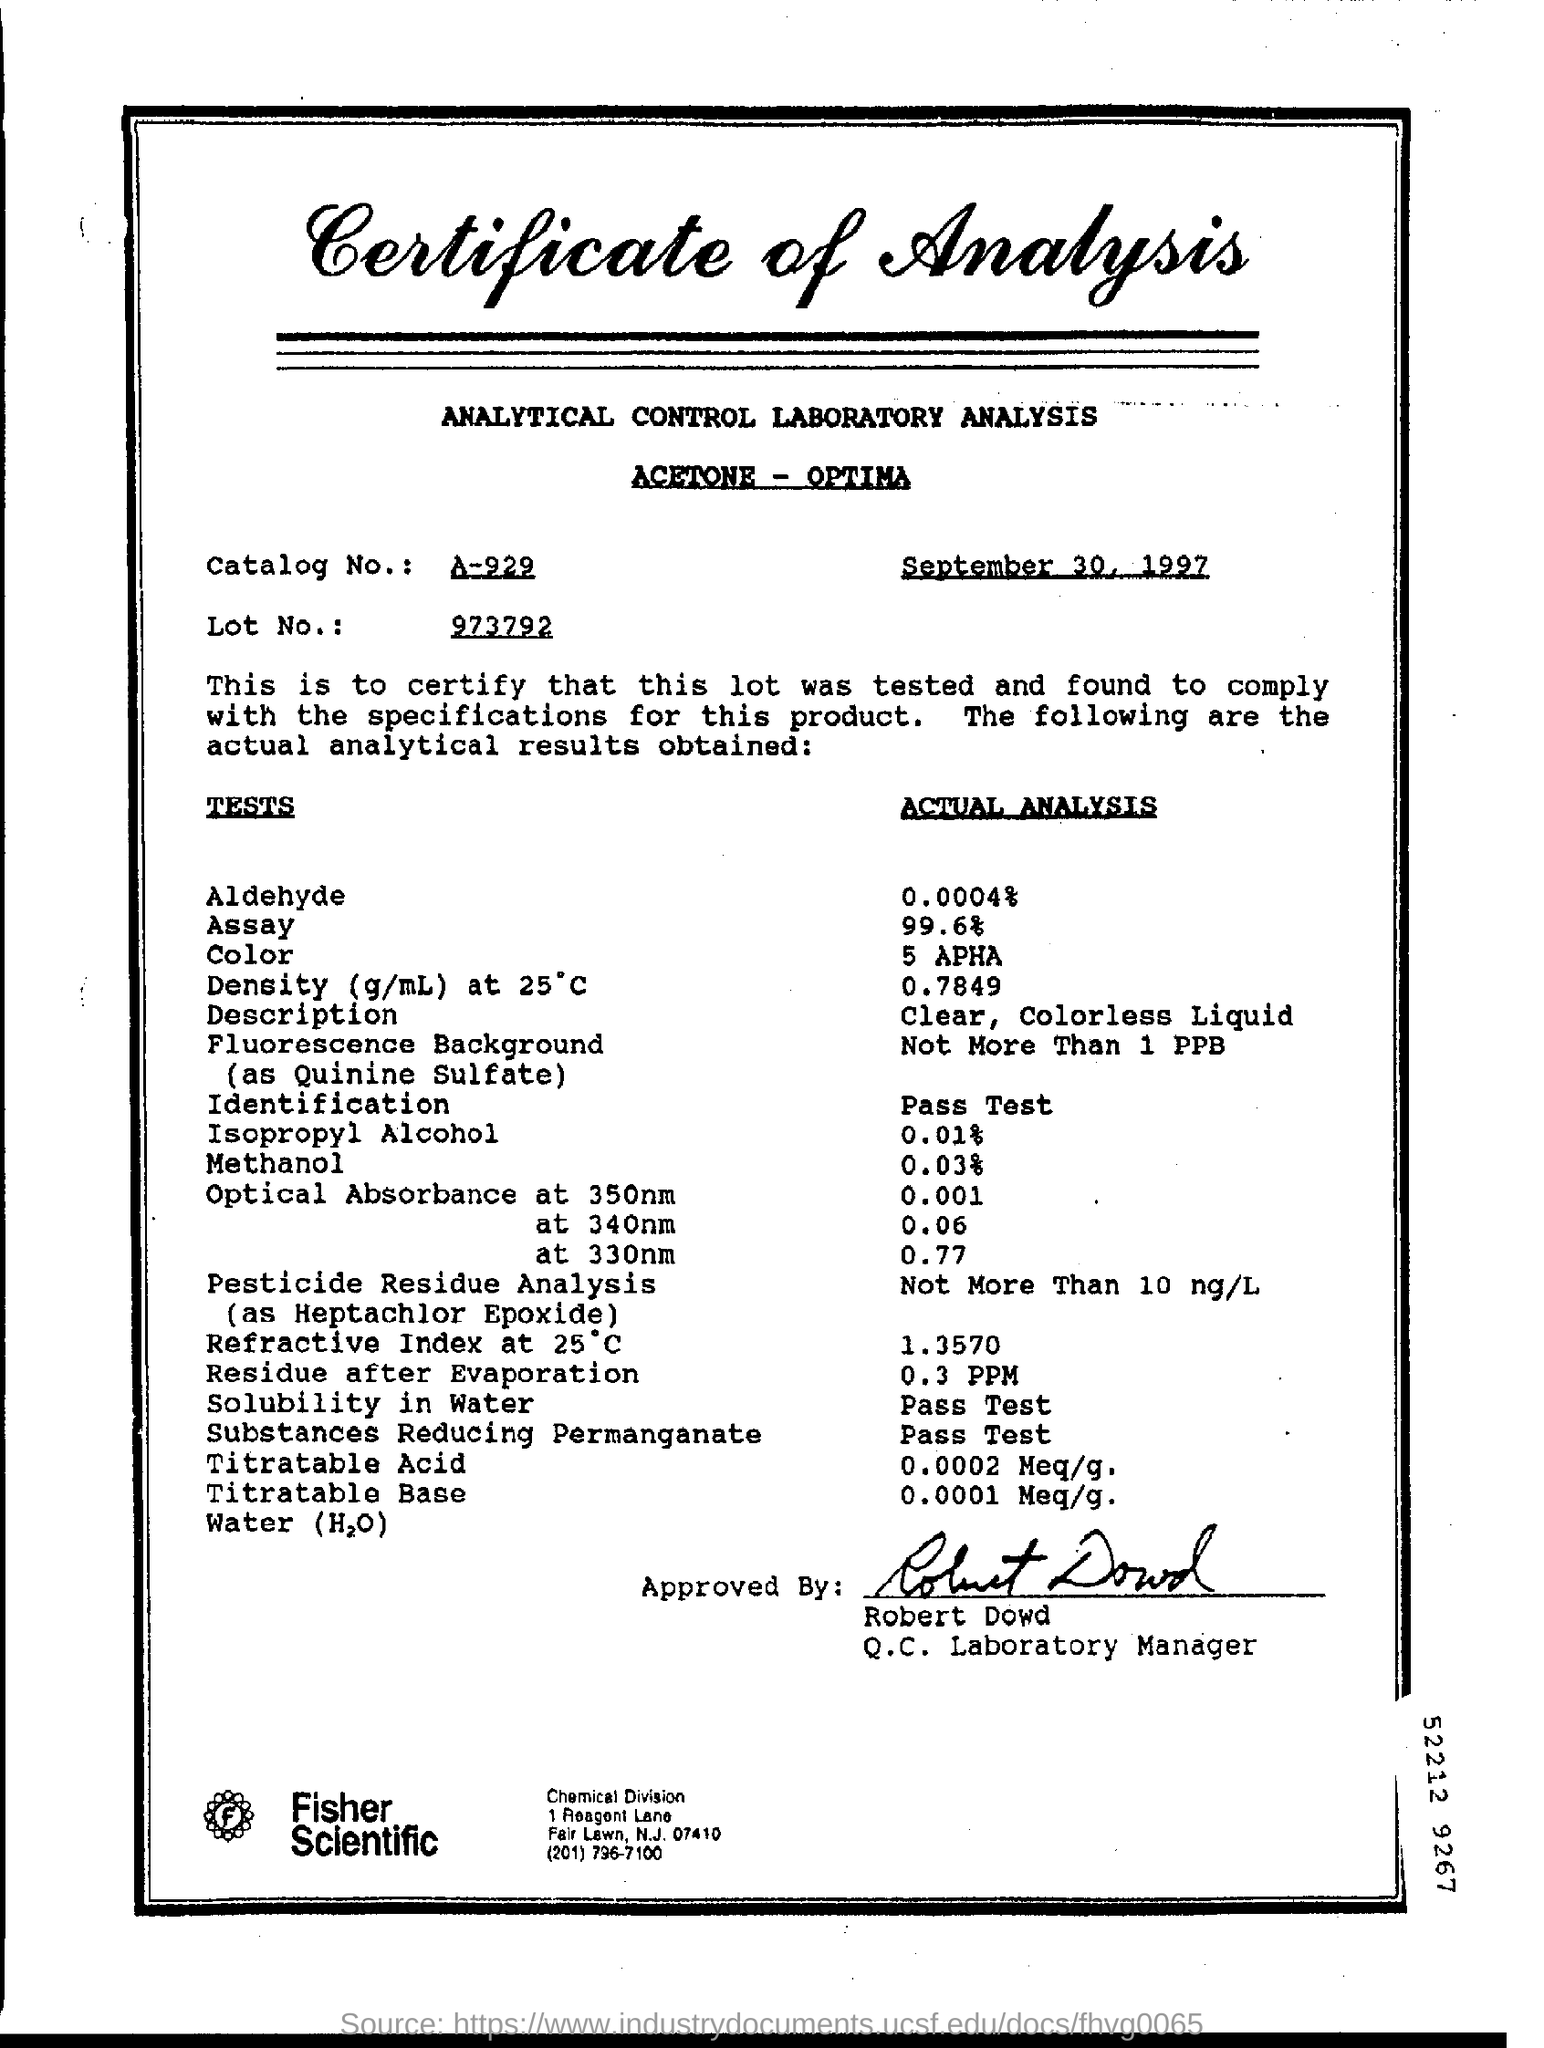What is written in the Letter Head ?
Give a very brief answer. Certificate of Analysis. What is the Catalog Number ?
Ensure brevity in your answer.  A-929. What is the date mentioned in the top of the document ?
Offer a terse response. September 30, 1997. Who is the Q.C. Laboratory Manager ?
Keep it short and to the point. Robert Dowd. What is the Actual Analysis of Color ?
Give a very brief answer. 5 APHA. 